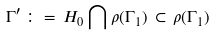<formula> <loc_0><loc_0><loc_500><loc_500>\Gamma ^ { \prime } \, \colon = \, H _ { 0 } \bigcap \rho ( \Gamma _ { 1 } ) \, \subset \, \rho ( \Gamma _ { 1 } )</formula> 